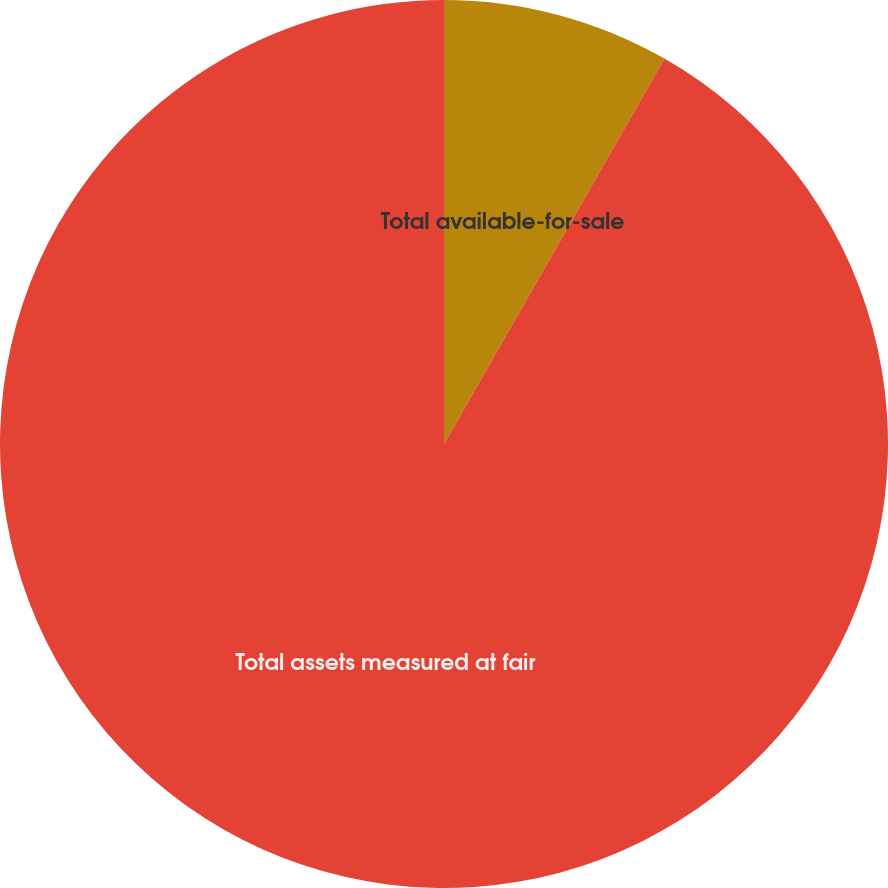Convert chart to OTSL. <chart><loc_0><loc_0><loc_500><loc_500><pie_chart><fcel>Total available-for-sale<fcel>Total assets measured at fair<nl><fcel>8.27%<fcel>91.73%<nl></chart> 